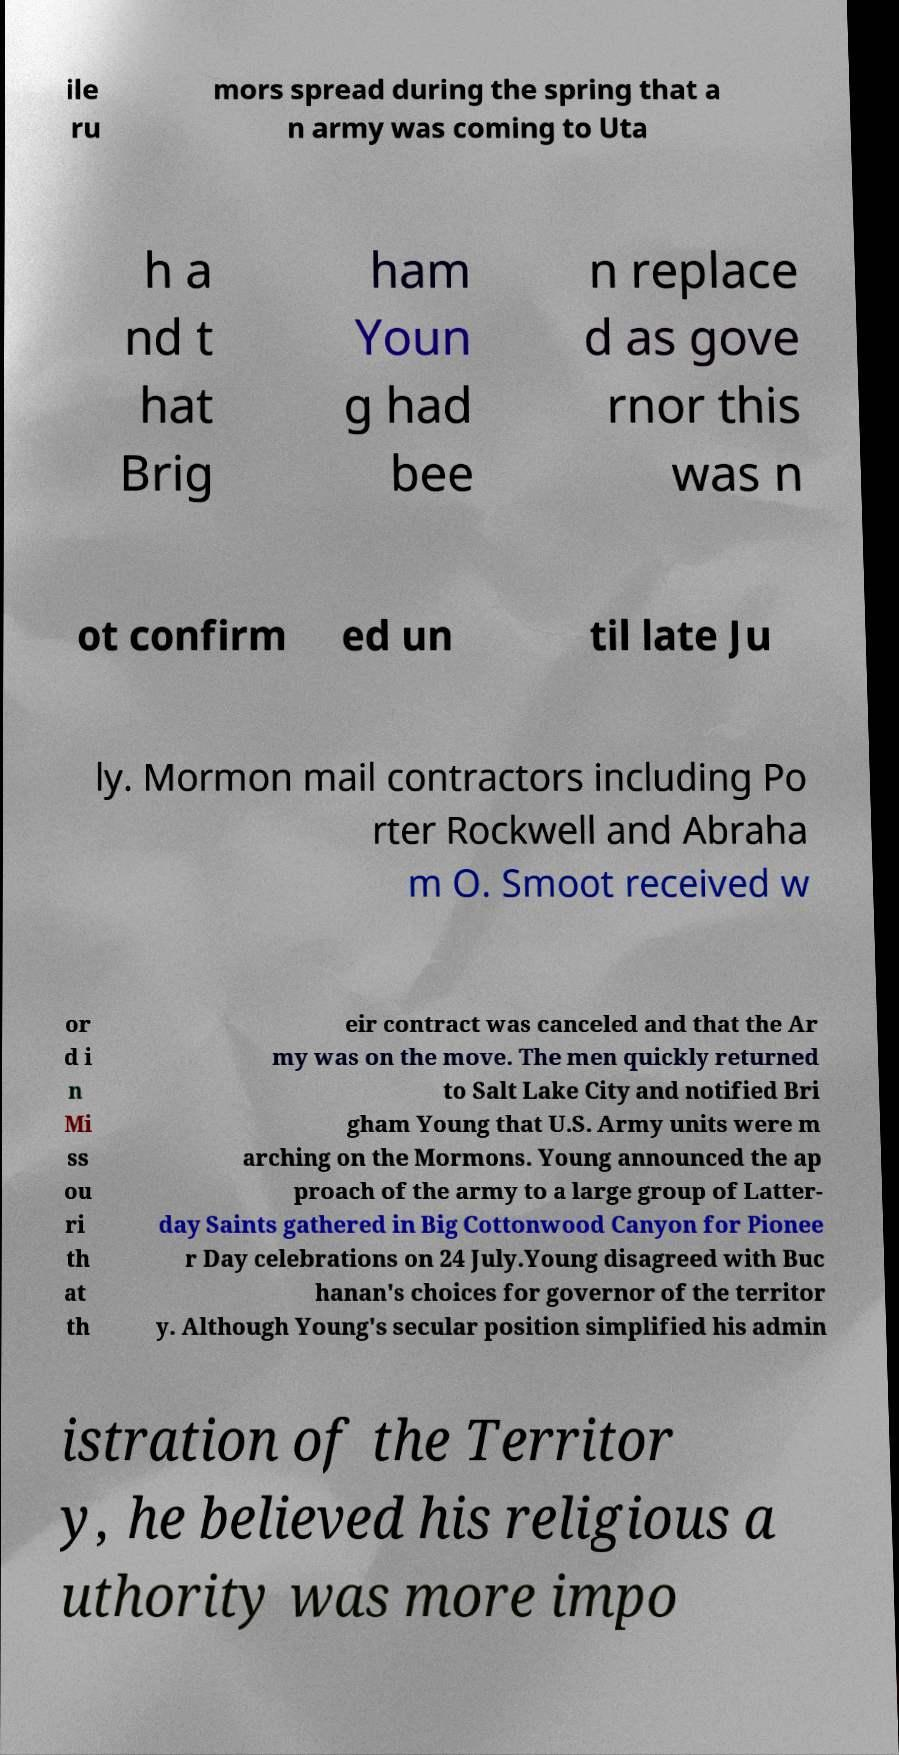Please read and relay the text visible in this image. What does it say? ile ru mors spread during the spring that a n army was coming to Uta h a nd t hat Brig ham Youn g had bee n replace d as gove rnor this was n ot confirm ed un til late Ju ly. Mormon mail contractors including Po rter Rockwell and Abraha m O. Smoot received w or d i n Mi ss ou ri th at th eir contract was canceled and that the Ar my was on the move. The men quickly returned to Salt Lake City and notified Bri gham Young that U.S. Army units were m arching on the Mormons. Young announced the ap proach of the army to a large group of Latter- day Saints gathered in Big Cottonwood Canyon for Pionee r Day celebrations on 24 July.Young disagreed with Buc hanan's choices for governor of the territor y. Although Young's secular position simplified his admin istration of the Territor y, he believed his religious a uthority was more impo 